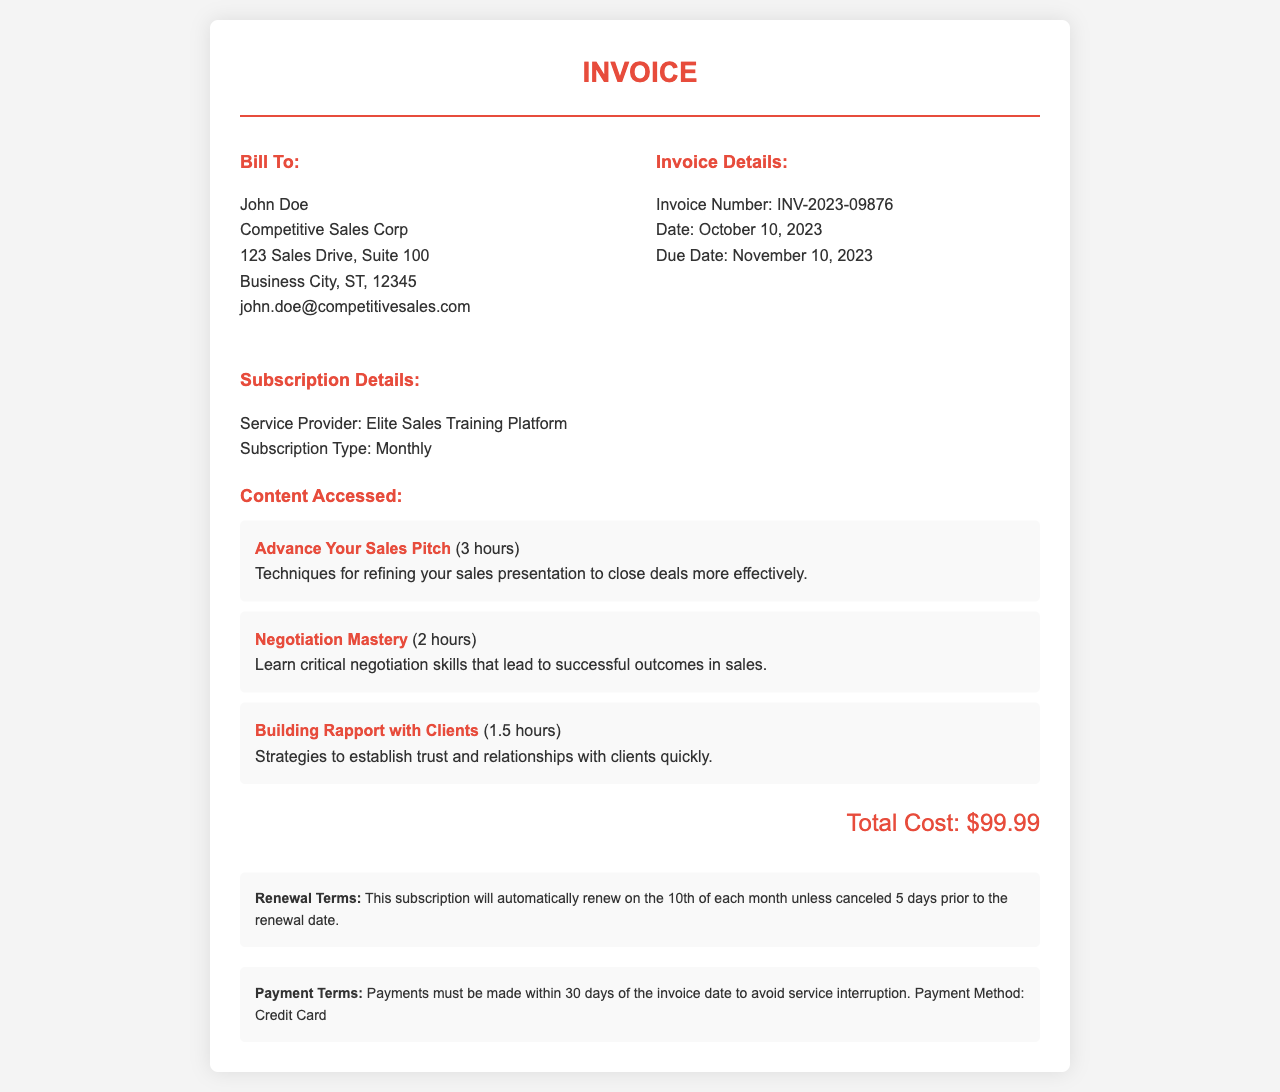what is the invoice number? The invoice number is explicitly mentioned in the document.
Answer: INV-2023-09876 who is billed in this invoice? The document contains a section labeled "Bill To" stating the name of the person or organization billed.
Answer: John Doe what is the total cost of the subscription? The total cost is clearly stated in the invoice, summarizing the charges associated with the subscription services.
Answer: $99.99 when is the due date for this invoice? The due date is included in the invoice details section, providing a clear deadline for payment.
Answer: November 10, 2023 what is the subscription type? The subscription type is listed under subscription details, defining the nature of the service contracted.
Answer: Monthly how many hours of content were accessed in "Advance Your Sales Pitch"? The hours of content are provided alongside the course name in the document.
Answer: 3 hours what are the renewal terms for the subscription? The renewal terms are outlined in a specific section of the invoice detailing the conditions for automatic renewal.
Answer: Automatically renew on the 10th of each month unless canceled 5 days prior which payment method is accepted? The payment method is mentioned in the payment terms section of the document.
Answer: Credit Card what is the service provider's name? The name of the service provider is clearly stated in the subscription details.
Answer: Elite Sales Training Platform 